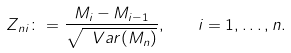<formula> <loc_0><loc_0><loc_500><loc_500>Z _ { n i } \colon = \frac { M _ { i } - M _ { i - 1 } } { \sqrt { \ V a r ( M _ { n } ) } } , \quad i = 1 , \dots , n .</formula> 